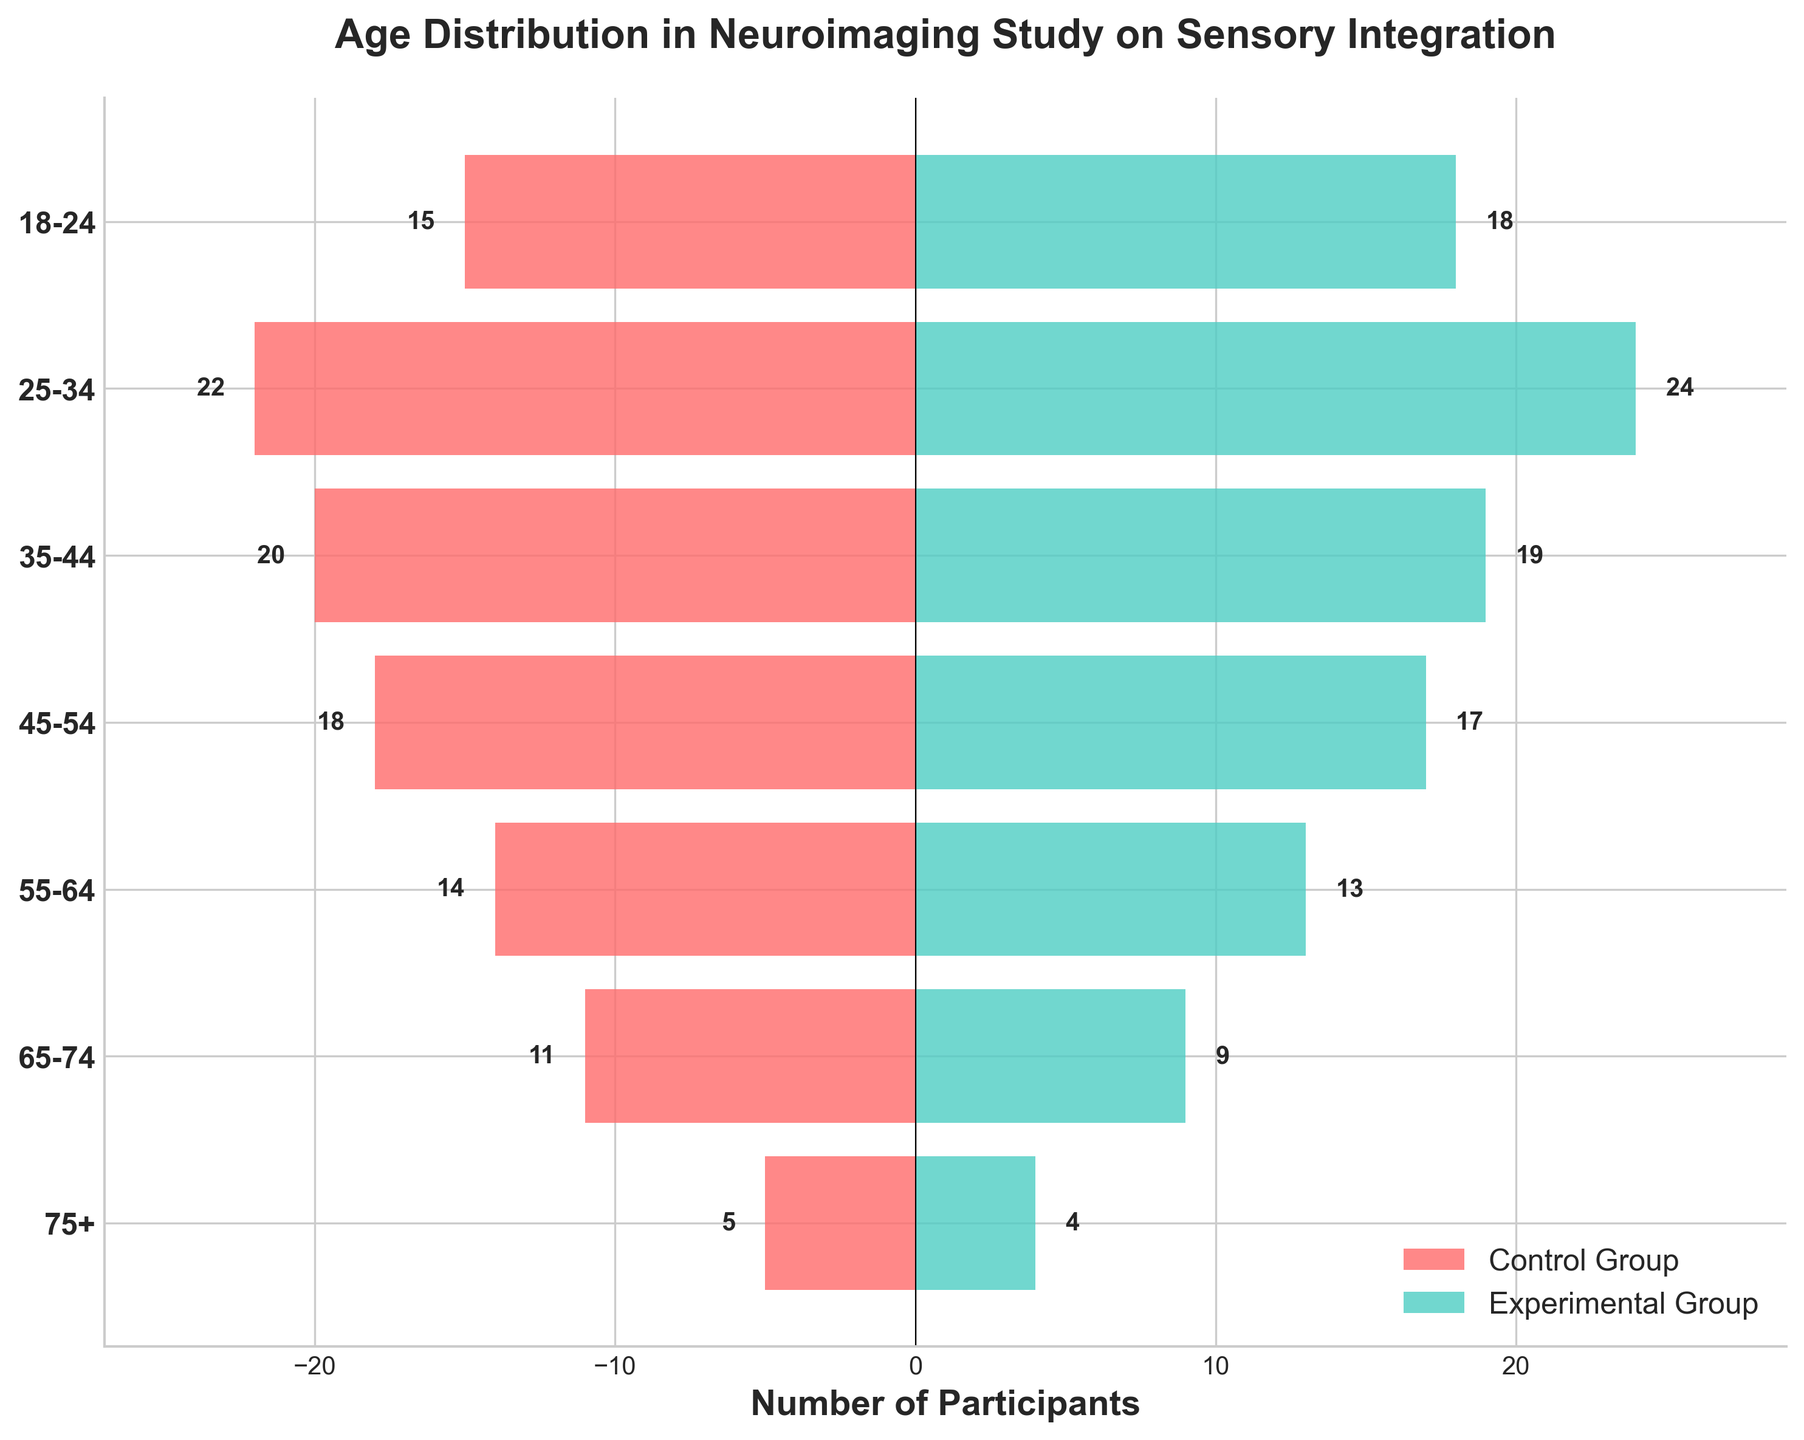What is the title of the plot? The title is located at the top of the plot and typically summarizes the content of the figure.
Answer: Age Distribution in Neuroimaging Study on Sensory Integration Which group has a higher number of participants aged 18-24? Observe the length of the bars corresponding to the 18-24 age group for both control and experimental groups. Compare their lengths.
Answer: Experimental Group How many participants are in the Control Group aged 35-44? Look at the bar representing the 35-44 age group on the Control Group side. The number should be labeled on the left side.
Answer: 20 What is the difference in the number of participants aged 75+ between the two groups? Locate the bars for the 75+ age group for both the Control and Experimental Groups. Subtract the smaller value from the larger value.
Answer: 1 Which age group has the smallest difference in participants between the control and experimental groups? Compare the differences between control and experimental group bars for each age group. Identify the smallest difference.
Answer: 75+ What is the sum of participants aged 25-34 in both groups? Add the participants from the Control Group (22) and the Experimental Group (24) together.
Answer: 46 Which age group has more participants overall in both groups combined? Sum the participants for each age group in both groups. The age group with the highest total number is the answer.
Answer: 25-34 How many total participants are there in the Experimental Group? Sum the participants in the Experimental Group across all age groups.
Answer: 104 Which age group shows the largest total number of participants split fairly evenly between both groups? For each age group, sum the participants in both groups and look for the largest total where the numbers are close to each other.
Answer: 25-34 (22 Control + 24 Experimental) What is the trend in the number of participants across age groups for both groups? Observe the bar lengths as you move from younger to older age brackets to identify any patterns or trends.
Answer: Decreasing as age increases 